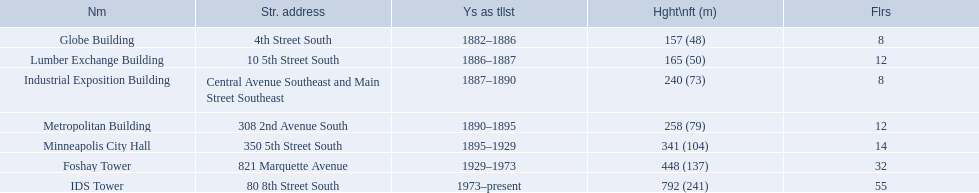What are the tallest buildings in minneapolis? Globe Building, Lumber Exchange Building, Industrial Exposition Building, Metropolitan Building, Minneapolis City Hall, Foshay Tower, IDS Tower. Which of those have 8 floors? Globe Building, Industrial Exposition Building. Of those, which is 240 ft tall? Industrial Exposition Building. 